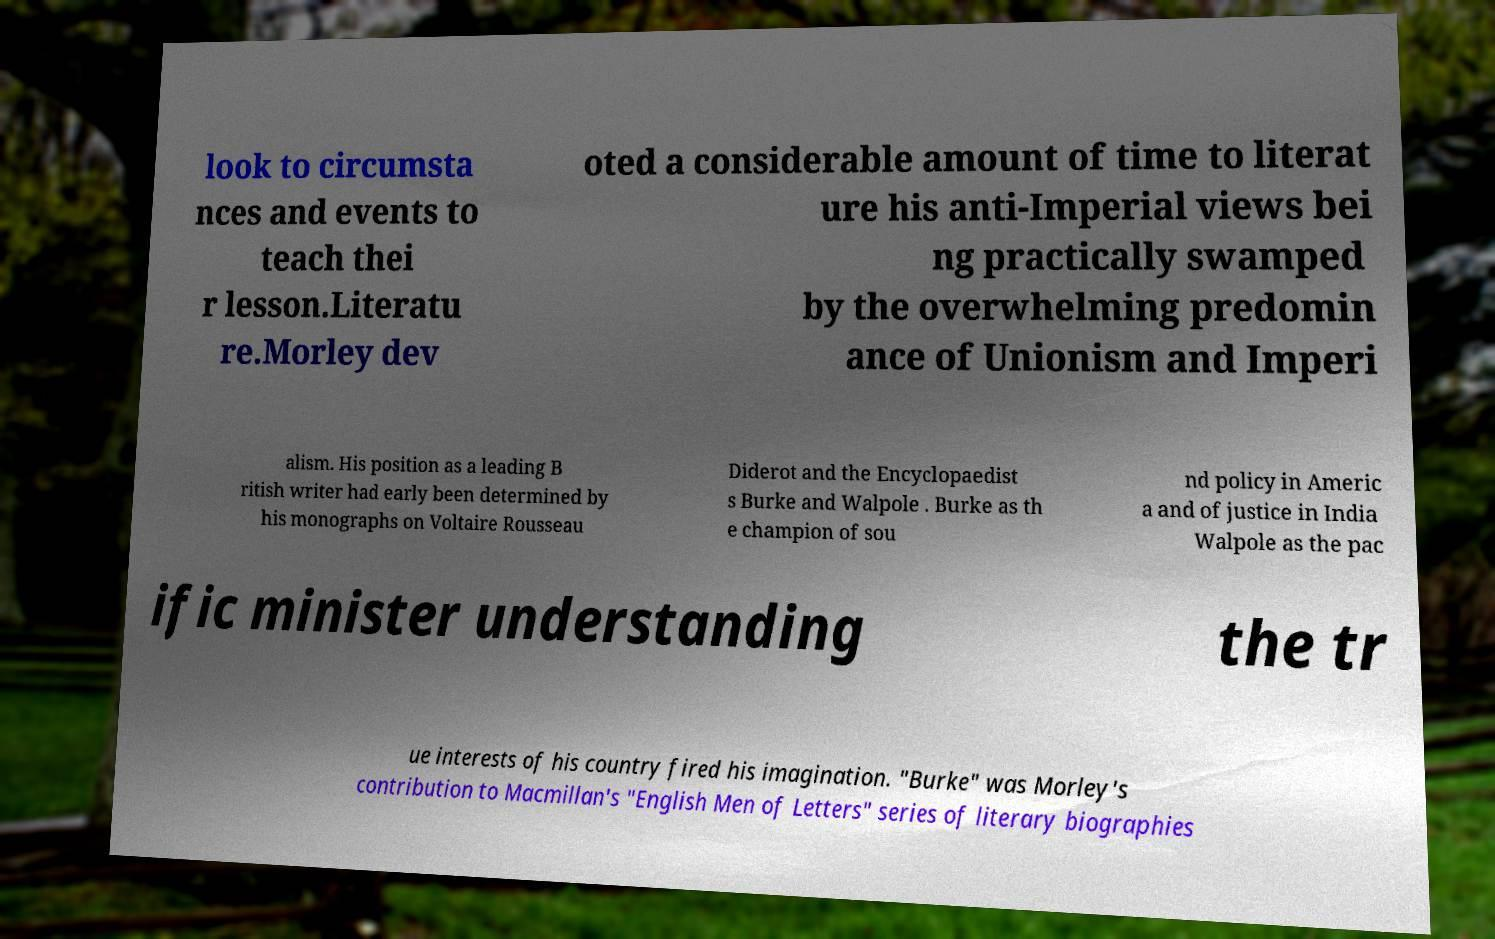What messages or text are displayed in this image? I need them in a readable, typed format. look to circumsta nces and events to teach thei r lesson.Literatu re.Morley dev oted a considerable amount of time to literat ure his anti-Imperial views bei ng practically swamped by the overwhelming predomin ance of Unionism and Imperi alism. His position as a leading B ritish writer had early been determined by his monographs on Voltaire Rousseau Diderot and the Encyclopaedist s Burke and Walpole . Burke as th e champion of sou nd policy in Americ a and of justice in India Walpole as the pac ific minister understanding the tr ue interests of his country fired his imagination. "Burke" was Morley's contribution to Macmillan's "English Men of Letters" series of literary biographies 